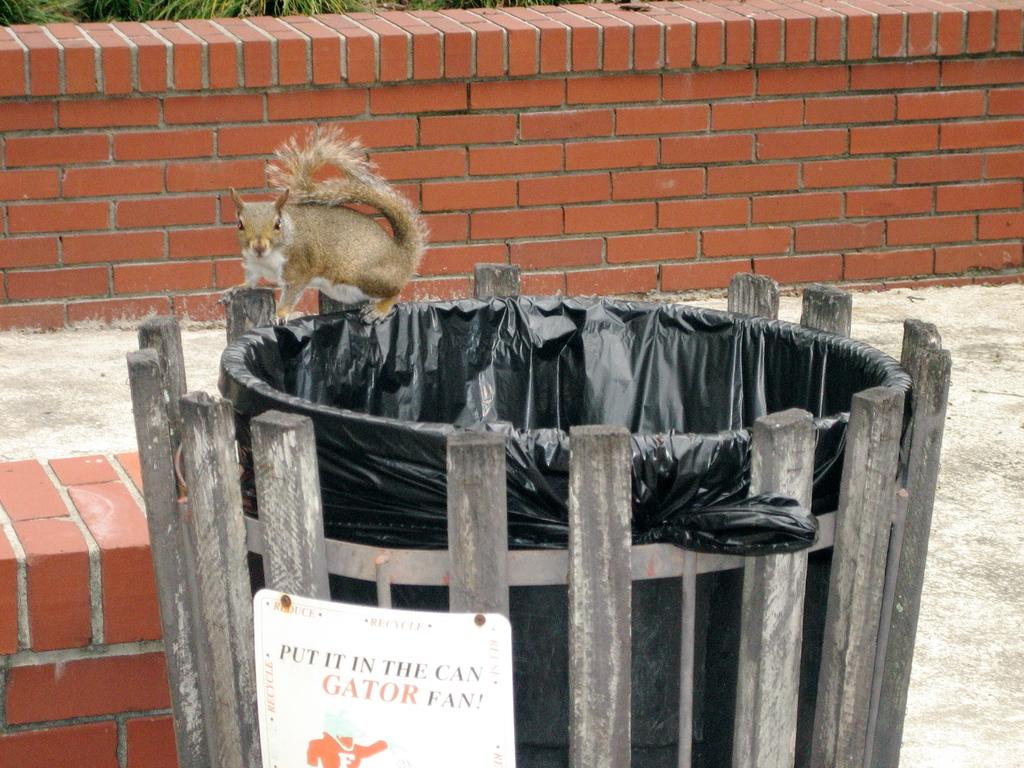What animal can be seen in the image? There is a squirrel in the image. Where is the squirrel located? The squirrel is on a bin. What else is on the bin besides the squirrel? There is a board placed on the bin. What can be seen in the background of the image? There is a wall in the background of the image. How many stars can be seen on the squirrel's back in the image? There are no stars visible on the squirrel's back in the image. 